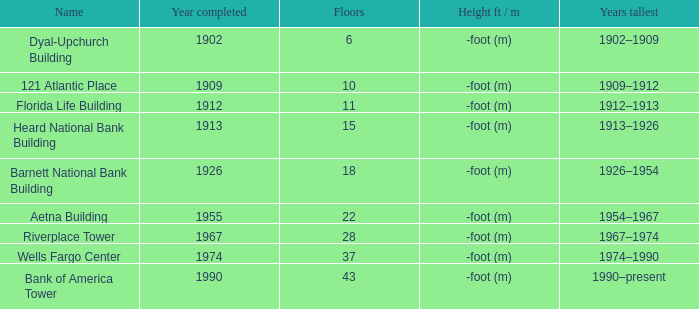What was the name of the building with 10 floors? 121 Atlantic Place. 